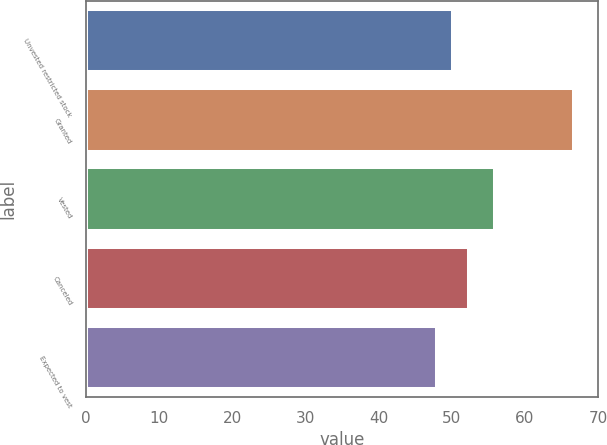Convert chart to OTSL. <chart><loc_0><loc_0><loc_500><loc_500><bar_chart><fcel>Unvested restricted stock<fcel>Granted<fcel>Vested<fcel>Canceled<fcel>Expected to vest<nl><fcel>50.16<fcel>66.68<fcel>55.93<fcel>52.32<fcel>47.99<nl></chart> 